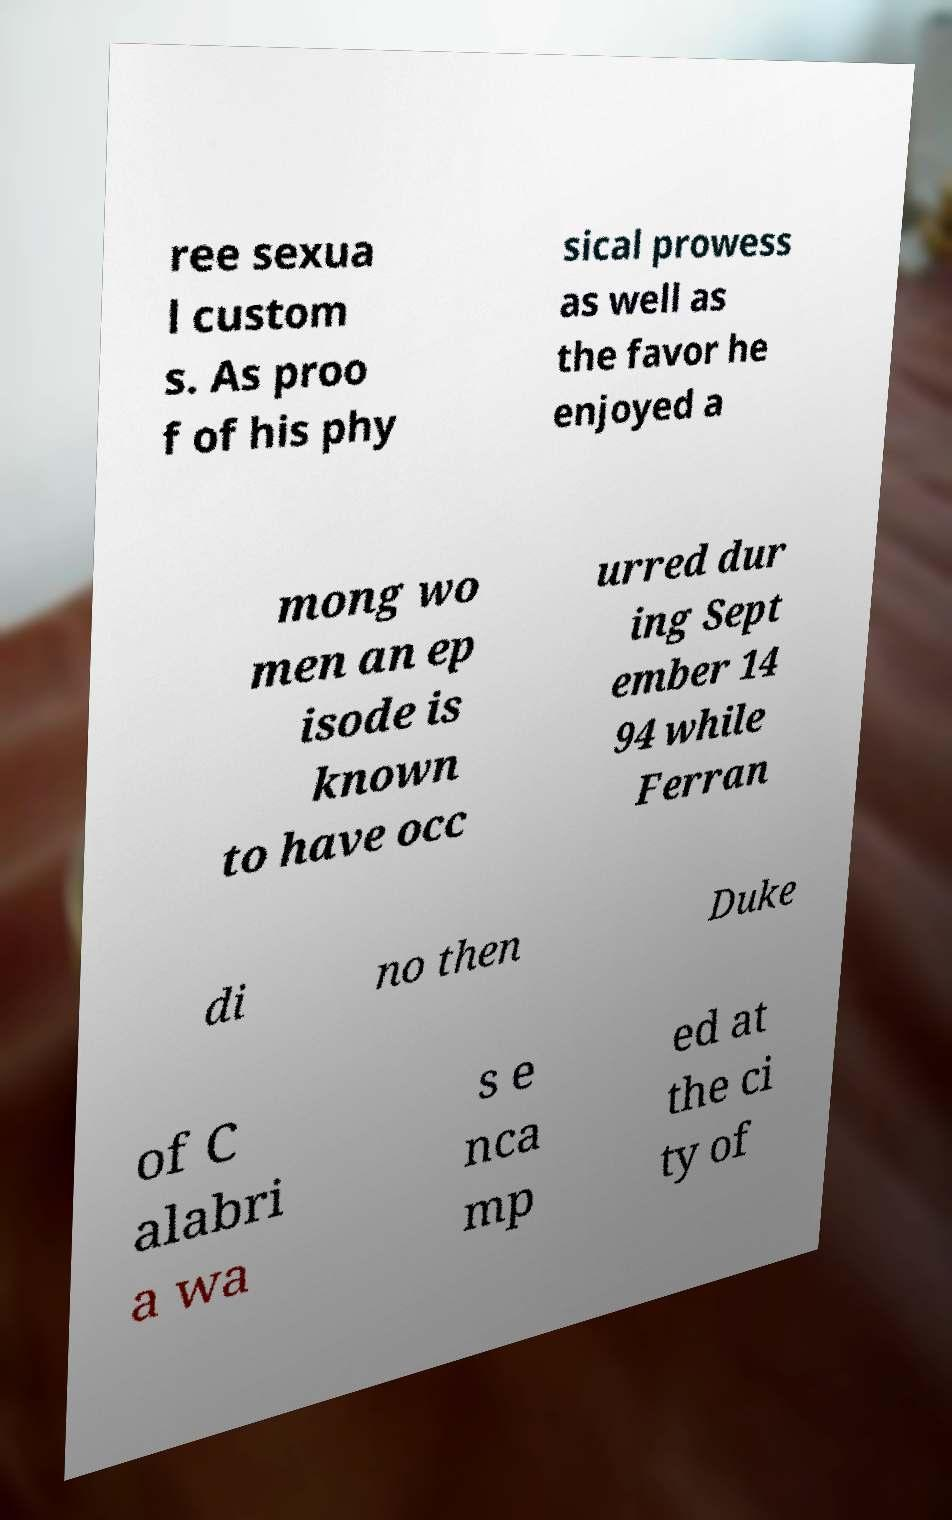What messages or text are displayed in this image? I need them in a readable, typed format. ree sexua l custom s. As proo f of his phy sical prowess as well as the favor he enjoyed a mong wo men an ep isode is known to have occ urred dur ing Sept ember 14 94 while Ferran di no then Duke of C alabri a wa s e nca mp ed at the ci ty of 